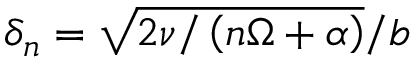Convert formula to latex. <formula><loc_0><loc_0><loc_500><loc_500>\delta _ { n } = \sqrt { 2 \nu / \left ( n \Omega + \alpha \right ) } / b</formula> 